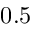<formula> <loc_0><loc_0><loc_500><loc_500>0 . 5</formula> 